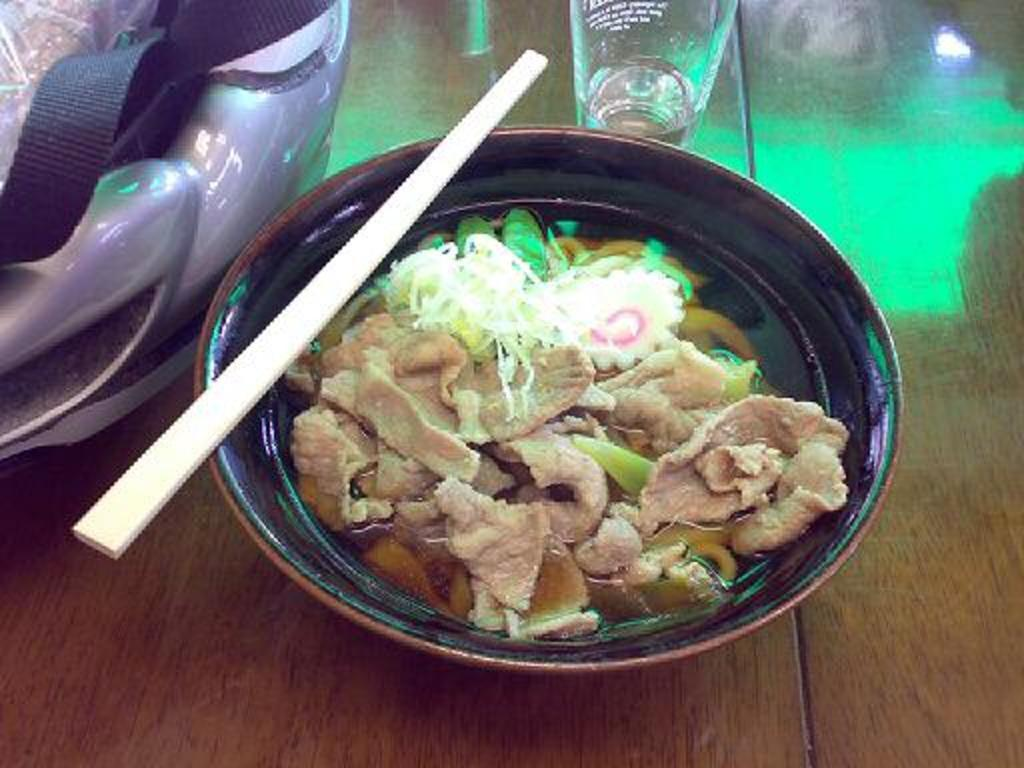What is in the serving bowl that is visible in the image? There is food in the serving bowl in the image. What utensil is visible in the image? Chopsticks are visible in the image. What type of container is present in the image? There is a glass tumbler in the image. What object is placed on the table in the image? There is an object placed on the table in the image, but the specific object is not mentioned in the facts. Can you see a giraffe inside the cave in the image? There is no cave or giraffe present in the image. What type of medical equipment is visible in the hospital in the image? There is no hospital or medical equipment present in the image. 